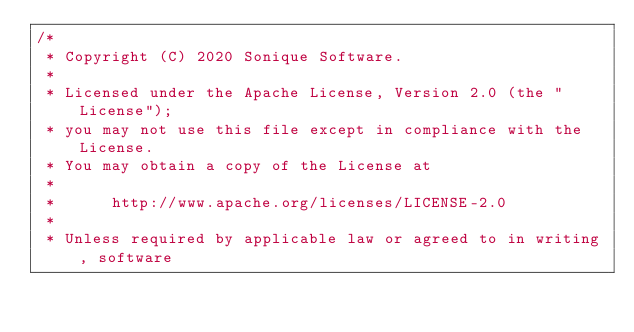<code> <loc_0><loc_0><loc_500><loc_500><_Kotlin_>/*
 * Copyright (C) 2020 Sonique Software.
 *
 * Licensed under the Apache License, Version 2.0 (the "License");
 * you may not use this file except in compliance with the License.
 * You may obtain a copy of the License at
 *
 *      http://www.apache.org/licenses/LICENSE-2.0
 *
 * Unless required by applicable law or agreed to in writing, software</code> 